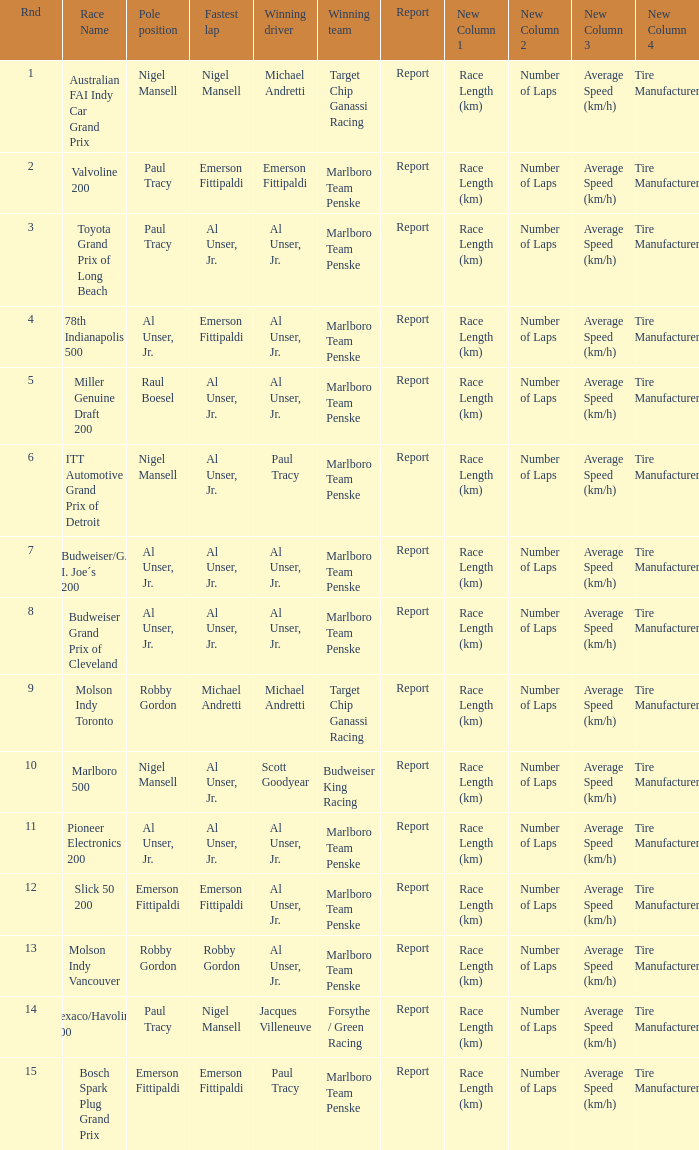Who was on the pole position in the Texaco/Havoline 200 race? Paul Tracy. 